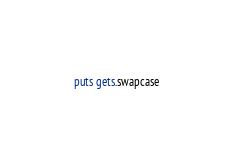Convert code to text. <code><loc_0><loc_0><loc_500><loc_500><_Ruby_>puts gets.swapcase</code> 